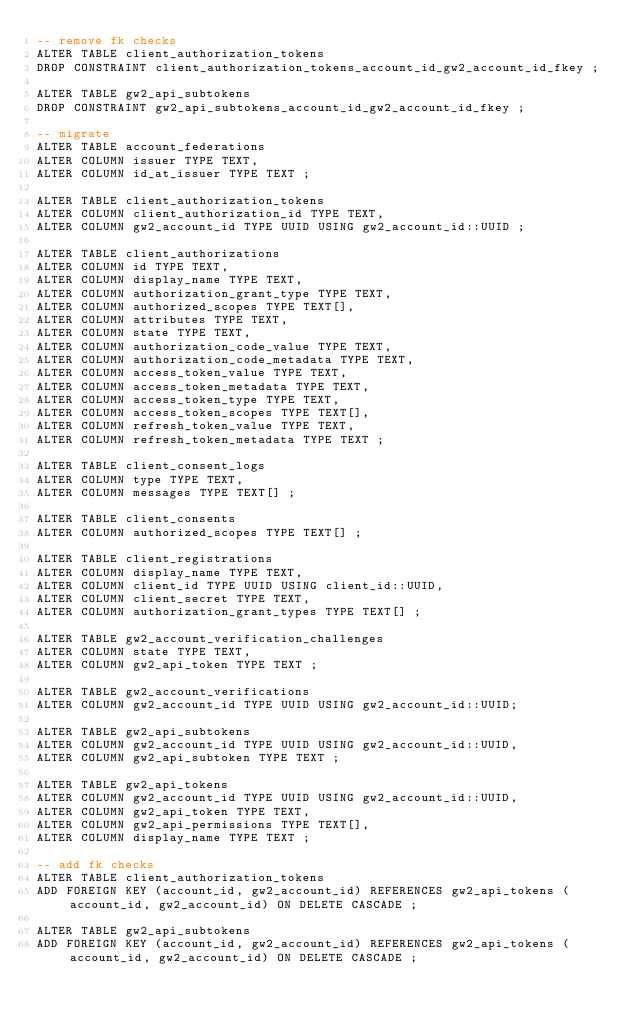Convert code to text. <code><loc_0><loc_0><loc_500><loc_500><_SQL_>-- remove fk checks
ALTER TABLE client_authorization_tokens
DROP CONSTRAINT client_authorization_tokens_account_id_gw2_account_id_fkey ;

ALTER TABLE gw2_api_subtokens
DROP CONSTRAINT gw2_api_subtokens_account_id_gw2_account_id_fkey ;

-- migrate
ALTER TABLE account_federations
ALTER COLUMN issuer TYPE TEXT,
ALTER COLUMN id_at_issuer TYPE TEXT ;

ALTER TABLE client_authorization_tokens
ALTER COLUMN client_authorization_id TYPE TEXT,
ALTER COLUMN gw2_account_id TYPE UUID USING gw2_account_id::UUID ;

ALTER TABLE client_authorizations
ALTER COLUMN id TYPE TEXT,
ALTER COLUMN display_name TYPE TEXT,
ALTER COLUMN authorization_grant_type TYPE TEXT,
ALTER COLUMN authorized_scopes TYPE TEXT[],
ALTER COLUMN attributes TYPE TEXT,
ALTER COLUMN state TYPE TEXT,
ALTER COLUMN authorization_code_value TYPE TEXT,
ALTER COLUMN authorization_code_metadata TYPE TEXT,
ALTER COLUMN access_token_value TYPE TEXT,
ALTER COLUMN access_token_metadata TYPE TEXT,
ALTER COLUMN access_token_type TYPE TEXT,
ALTER COLUMN access_token_scopes TYPE TEXT[],
ALTER COLUMN refresh_token_value TYPE TEXT,
ALTER COLUMN refresh_token_metadata TYPE TEXT ;

ALTER TABLE client_consent_logs
ALTER COLUMN type TYPE TEXT,
ALTER COLUMN messages TYPE TEXT[] ;

ALTER TABLE client_consents
ALTER COLUMN authorized_scopes TYPE TEXT[] ;

ALTER TABLE client_registrations
ALTER COLUMN display_name TYPE TEXT,
ALTER COLUMN client_id TYPE UUID USING client_id::UUID,
ALTER COLUMN client_secret TYPE TEXT,
ALTER COLUMN authorization_grant_types TYPE TEXT[] ;

ALTER TABLE gw2_account_verification_challenges
ALTER COLUMN state TYPE TEXT,
ALTER COLUMN gw2_api_token TYPE TEXT ;

ALTER TABLE gw2_account_verifications
ALTER COLUMN gw2_account_id TYPE UUID USING gw2_account_id::UUID;

ALTER TABLE gw2_api_subtokens
ALTER COLUMN gw2_account_id TYPE UUID USING gw2_account_id::UUID,
ALTER COLUMN gw2_api_subtoken TYPE TEXT ;

ALTER TABLE gw2_api_tokens
ALTER COLUMN gw2_account_id TYPE UUID USING gw2_account_id::UUID,
ALTER COLUMN gw2_api_token TYPE TEXT,
ALTER COLUMN gw2_api_permissions TYPE TEXT[],
ALTER COLUMN display_name TYPE TEXT ;

-- add fk checks
ALTER TABLE client_authorization_tokens
ADD FOREIGN KEY (account_id, gw2_account_id) REFERENCES gw2_api_tokens (account_id, gw2_account_id) ON DELETE CASCADE ;

ALTER TABLE gw2_api_subtokens
ADD FOREIGN KEY (account_id, gw2_account_id) REFERENCES gw2_api_tokens (account_id, gw2_account_id) ON DELETE CASCADE ;
</code> 